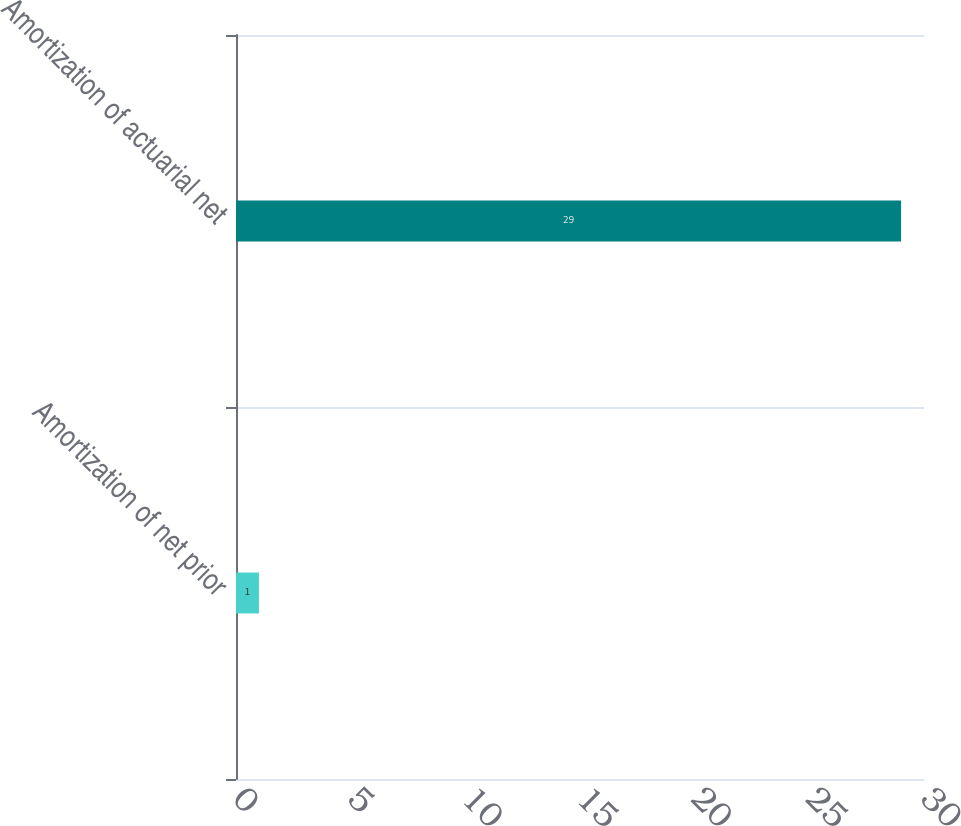<chart> <loc_0><loc_0><loc_500><loc_500><bar_chart><fcel>Amortization of net prior<fcel>Amortization of actuarial net<nl><fcel>1<fcel>29<nl></chart> 